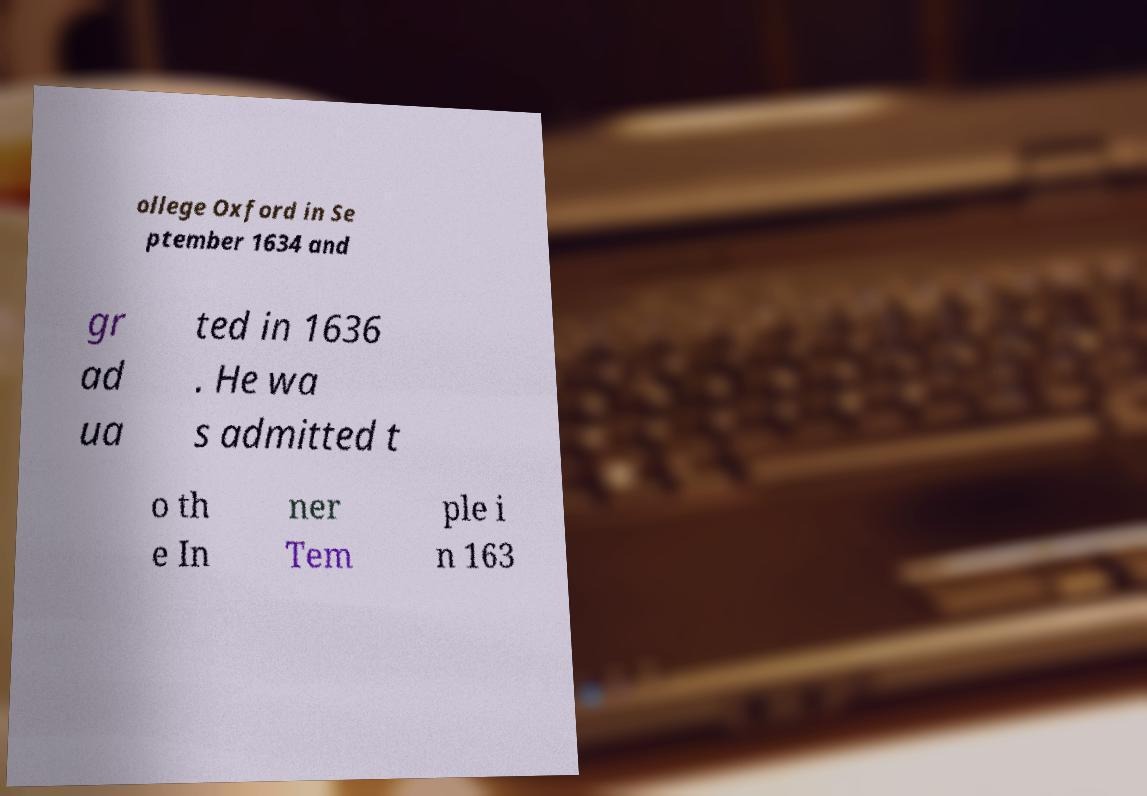What messages or text are displayed in this image? I need them in a readable, typed format. ollege Oxford in Se ptember 1634 and gr ad ua ted in 1636 . He wa s admitted t o th e In ner Tem ple i n 163 